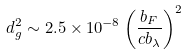Convert formula to latex. <formula><loc_0><loc_0><loc_500><loc_500>d _ { g } ^ { 2 } \sim 2 . 5 \times 1 0 ^ { - 8 } \left ( \frac { b _ { F } } { c b _ { \lambda } } \right ) ^ { 2 }</formula> 